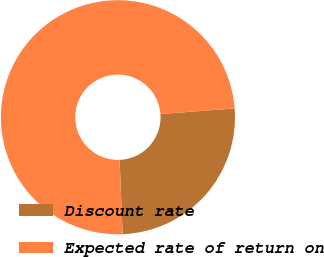<chart> <loc_0><loc_0><loc_500><loc_500><pie_chart><fcel>Discount rate<fcel>Expected rate of return on<nl><fcel>25.56%<fcel>74.44%<nl></chart> 